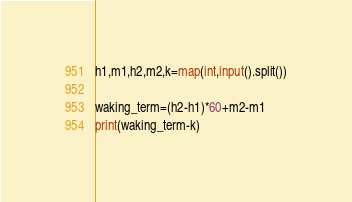Convert code to text. <code><loc_0><loc_0><loc_500><loc_500><_Python_>h1,m1,h2,m2,k=map(int,input().split())

waking_term=(h2-h1)*60+m2-m1
print(waking_term-k)</code> 